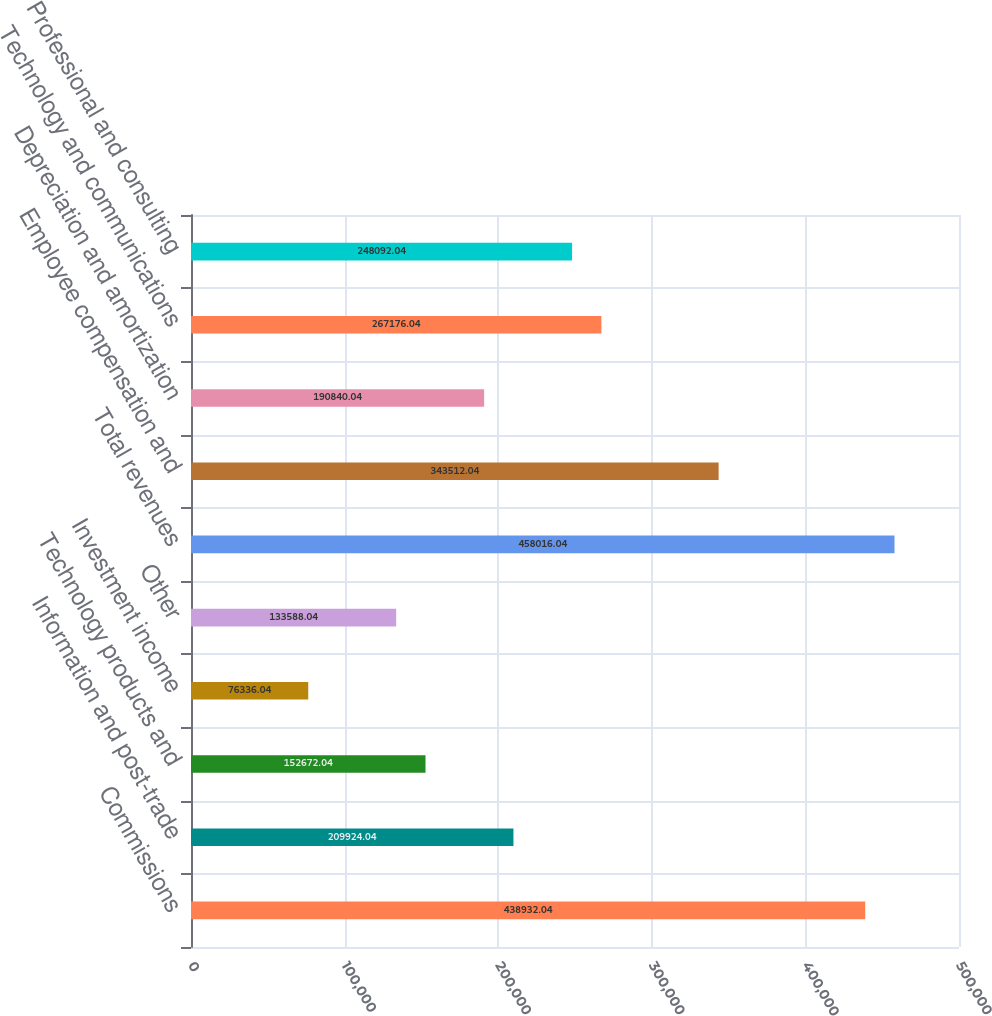Convert chart. <chart><loc_0><loc_0><loc_500><loc_500><bar_chart><fcel>Commissions<fcel>Information and post-trade<fcel>Technology products and<fcel>Investment income<fcel>Other<fcel>Total revenues<fcel>Employee compensation and<fcel>Depreciation and amortization<fcel>Technology and communications<fcel>Professional and consulting<nl><fcel>438932<fcel>209924<fcel>152672<fcel>76336<fcel>133588<fcel>458016<fcel>343512<fcel>190840<fcel>267176<fcel>248092<nl></chart> 